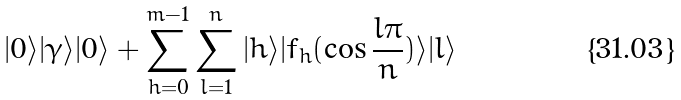Convert formula to latex. <formula><loc_0><loc_0><loc_500><loc_500>| 0 \rangle | \gamma \rangle | 0 \rangle + \sum _ { h = 0 } ^ { m - 1 } \sum _ { l = 1 } ^ { n } | h \rangle | f _ { h } ( \cos \frac { l \pi } { n } ) \rangle | l \rangle</formula> 